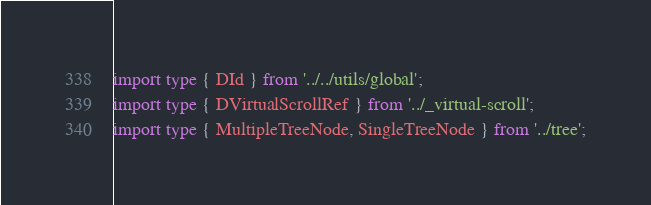<code> <loc_0><loc_0><loc_500><loc_500><_TypeScript_>import type { DId } from '../../utils/global';
import type { DVirtualScrollRef } from '../_virtual-scroll';
import type { MultipleTreeNode, SingleTreeNode } from '../tree';</code> 